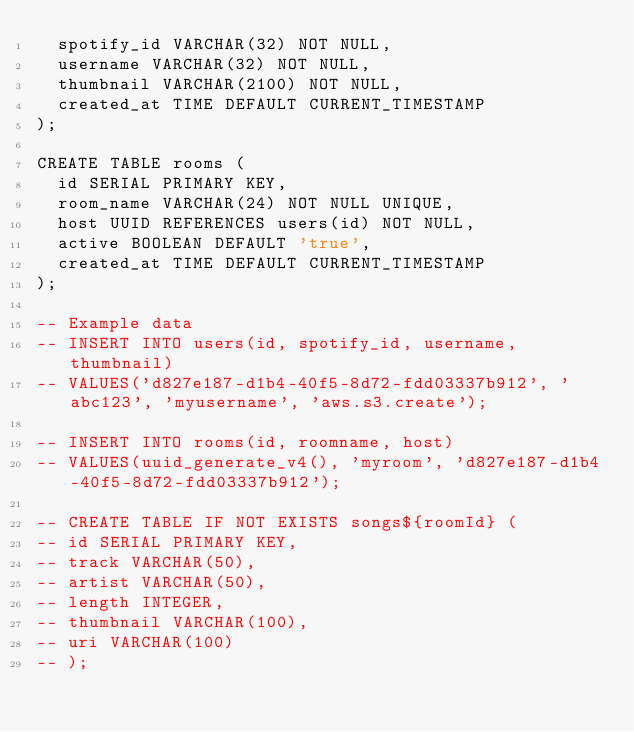Convert code to text. <code><loc_0><loc_0><loc_500><loc_500><_SQL_>  spotify_id VARCHAR(32) NOT NULL,
  username VARCHAR(32) NOT NULL,
  thumbnail VARCHAR(2100) NOT NULL,
  created_at TIME DEFAULT CURRENT_TIMESTAMP
);

CREATE TABLE rooms (
  id SERIAL PRIMARY KEY,
  room_name VARCHAR(24) NOT NULL UNIQUE,
  host UUID REFERENCES users(id) NOT NULL,
  active BOOLEAN DEFAULT 'true',
  created_at TIME DEFAULT CURRENT_TIMESTAMP
);

-- Example data
-- INSERT INTO users(id, spotify_id, username, thumbnail)
-- VALUES('d827e187-d1b4-40f5-8d72-fdd03337b912', 'abc123', 'myusername', 'aws.s3.create');

-- INSERT INTO rooms(id, roomname, host)
-- VALUES(uuid_generate_v4(), 'myroom', 'd827e187-d1b4-40f5-8d72-fdd03337b912');

-- CREATE TABLE IF NOT EXISTS songs${roomId} (
-- id SERIAL PRIMARY KEY,
-- track VARCHAR(50),
-- artist VARCHAR(50),
-- length INTEGER,
-- thumbnail VARCHAR(100),
-- uri VARCHAR(100)
-- );</code> 